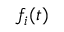Convert formula to latex. <formula><loc_0><loc_0><loc_500><loc_500>f _ { i } ( t )</formula> 